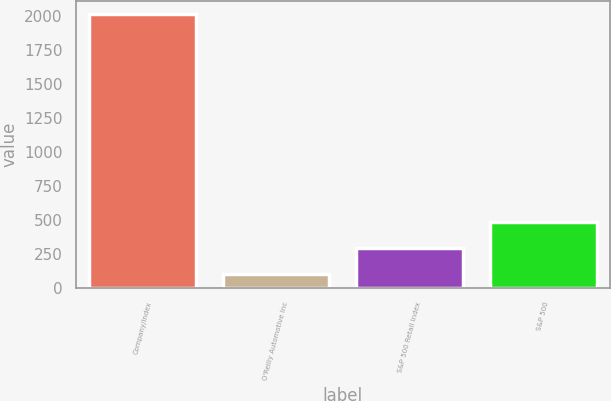<chart> <loc_0><loc_0><loc_500><loc_500><bar_chart><fcel>Company/Index<fcel>O'Reilly Automotive Inc<fcel>S&P 500 Retail Index<fcel>S&P 500<nl><fcel>2010<fcel>100<fcel>291<fcel>482<nl></chart> 